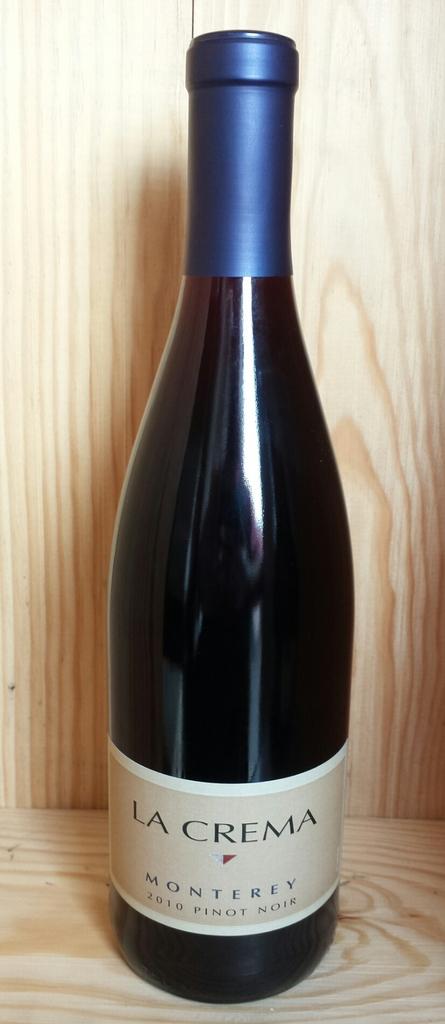What is the brand of wine?
Your answer should be compact. La crema. What type of wine is this?
Make the answer very short. Pinot noir. 